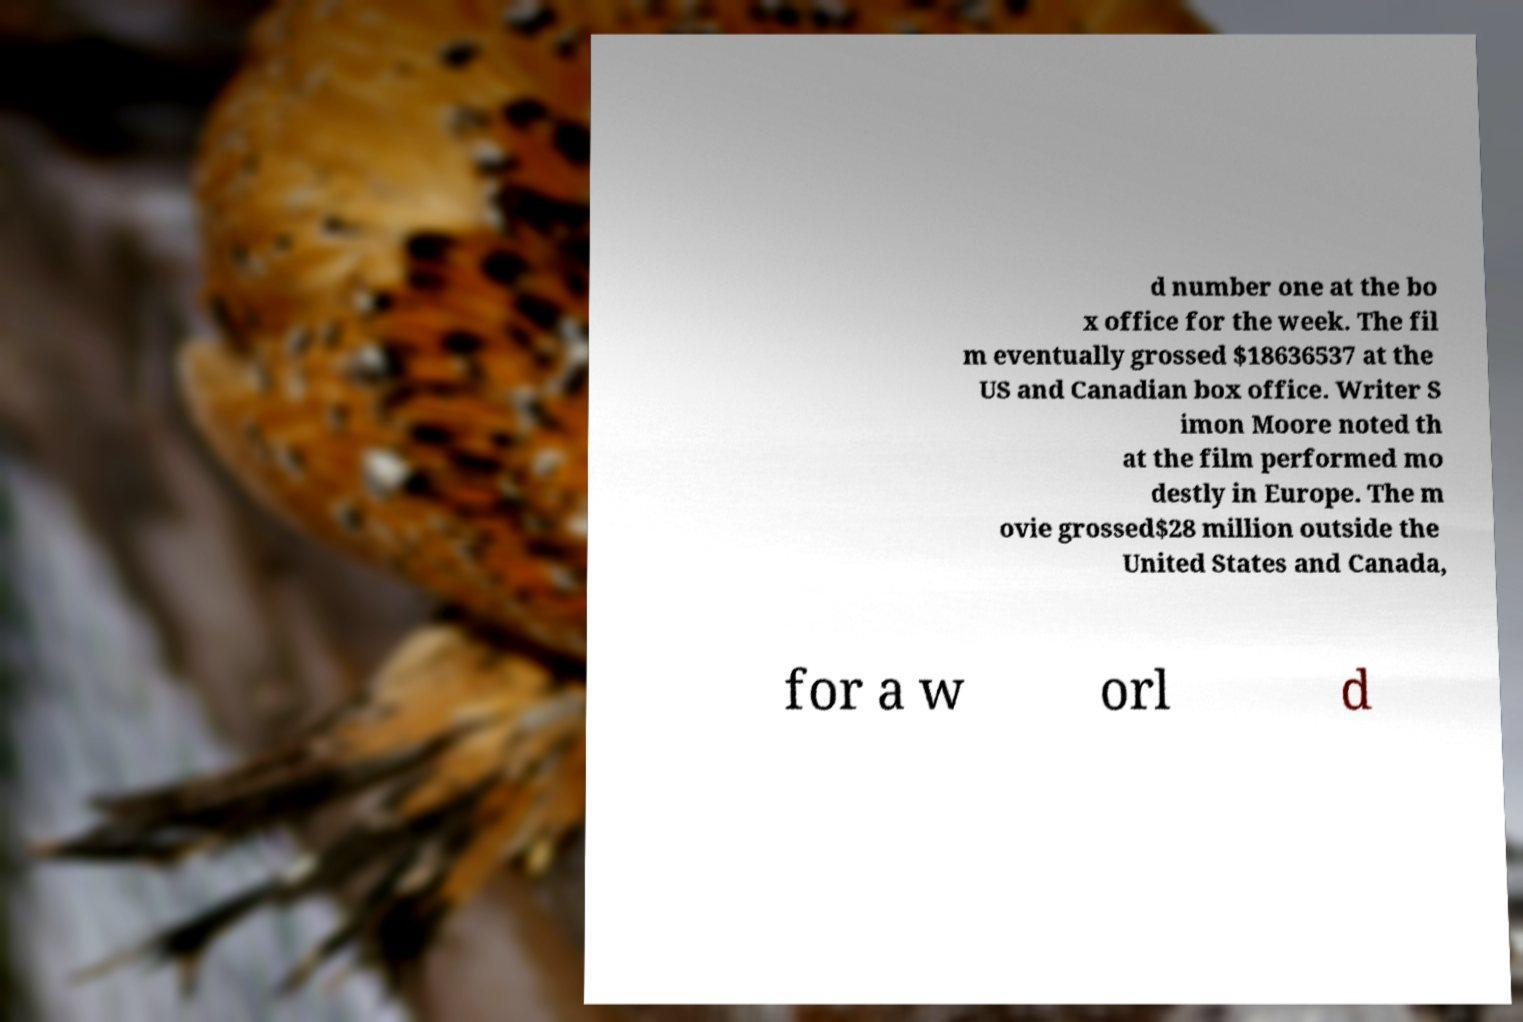I need the written content from this picture converted into text. Can you do that? d number one at the bo x office for the week. The fil m eventually grossed $18636537 at the US and Canadian box office. Writer S imon Moore noted th at the film performed mo destly in Europe. The m ovie grossed$28 million outside the United States and Canada, for a w orl d 